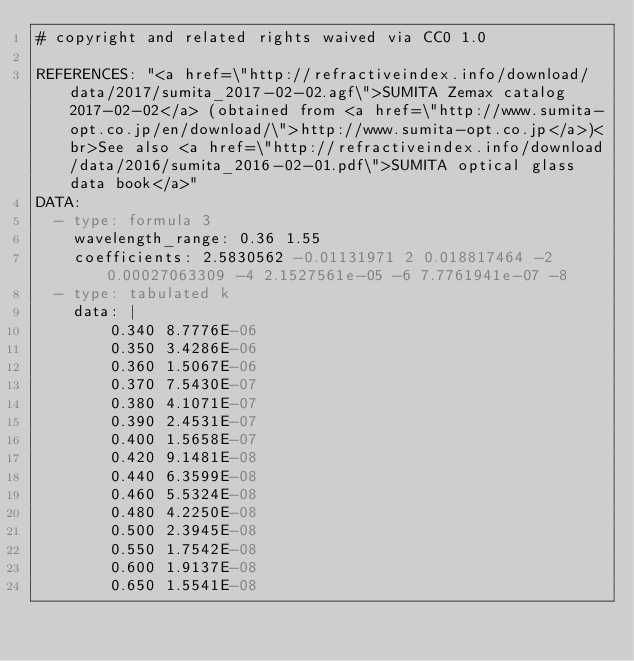<code> <loc_0><loc_0><loc_500><loc_500><_YAML_># copyright and related rights waived via CC0 1.0

REFERENCES: "<a href=\"http://refractiveindex.info/download/data/2017/sumita_2017-02-02.agf\">SUMITA Zemax catalog 2017-02-02</a> (obtained from <a href=\"http://www.sumita-opt.co.jp/en/download/\">http://www.sumita-opt.co.jp</a>)<br>See also <a href=\"http://refractiveindex.info/download/data/2016/sumita_2016-02-01.pdf\">SUMITA optical glass data book</a>"
DATA:
  - type: formula 3 
    wavelength_range: 0.36 1.55
    coefficients: 2.5830562 -0.01131971 2 0.018817464 -2 0.00027063309 -4 2.1527561e-05 -6 7.7761941e-07 -8
  - type: tabulated k
    data: |
        0.340 8.7776E-06
        0.350 3.4286E-06
        0.360 1.5067E-06
        0.370 7.5430E-07
        0.380 4.1071E-07
        0.390 2.4531E-07
        0.400 1.5658E-07
        0.420 9.1481E-08
        0.440 6.3599E-08
        0.460 5.5324E-08
        0.480 4.2250E-08
        0.500 2.3945E-08
        0.550 1.7542E-08
        0.600 1.9137E-08
        0.650 1.5541E-08</code> 